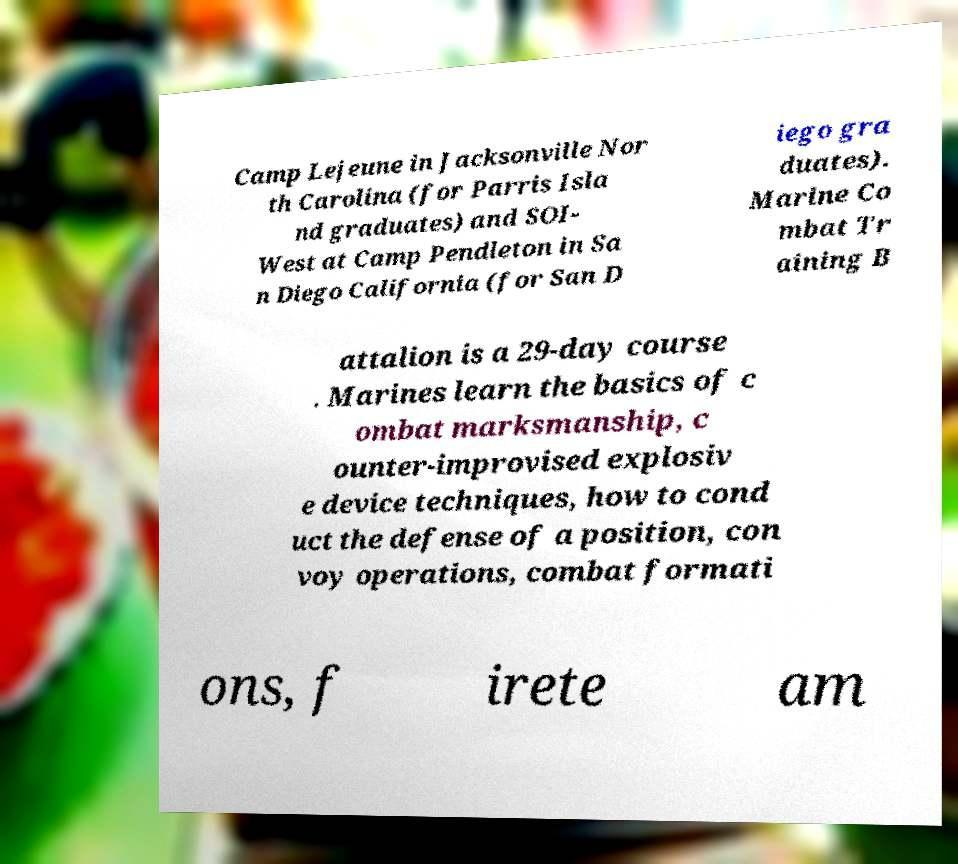Could you assist in decoding the text presented in this image and type it out clearly? Camp Lejeune in Jacksonville Nor th Carolina (for Parris Isla nd graduates) and SOI- West at Camp Pendleton in Sa n Diego California (for San D iego gra duates). Marine Co mbat Tr aining B attalion is a 29-day course . Marines learn the basics of c ombat marksmanship, c ounter-improvised explosiv e device techniques, how to cond uct the defense of a position, con voy operations, combat formati ons, f irete am 